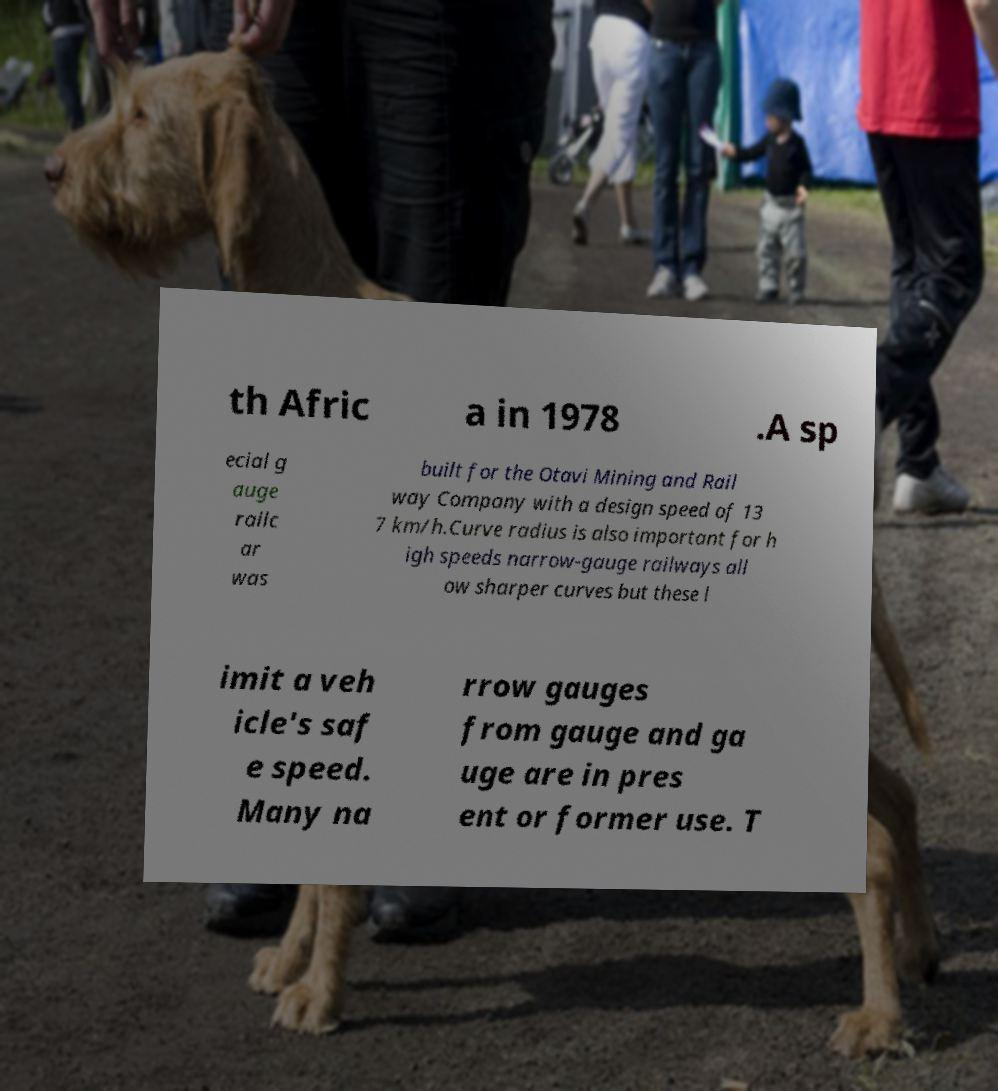Can you accurately transcribe the text from the provided image for me? th Afric a in 1978 .A sp ecial g auge railc ar was built for the Otavi Mining and Rail way Company with a design speed of 13 7 km/h.Curve radius is also important for h igh speeds narrow-gauge railways all ow sharper curves but these l imit a veh icle's saf e speed. Many na rrow gauges from gauge and ga uge are in pres ent or former use. T 